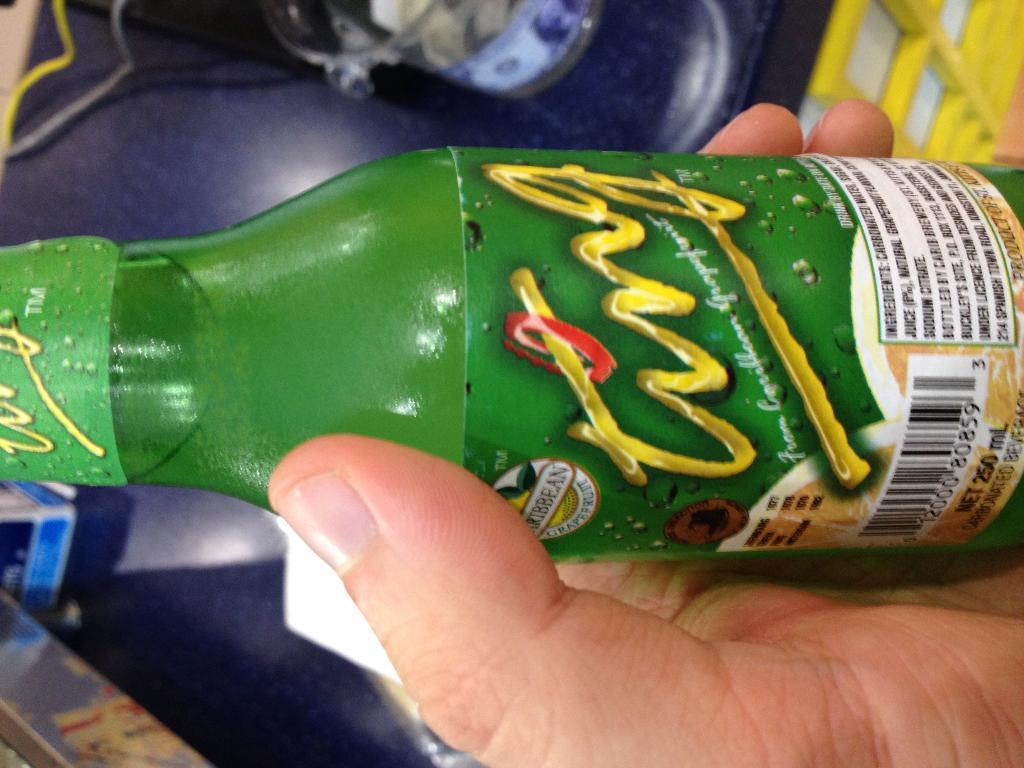Please provide a concise description of this image. In this image I can see a hand of a person is holding a bottle. 